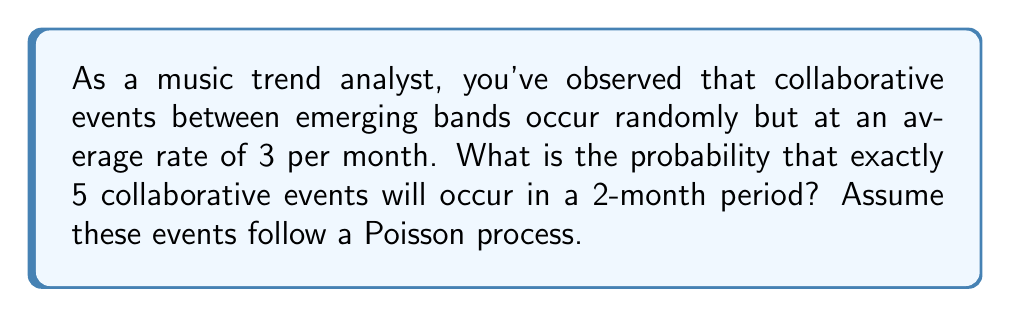What is the answer to this math problem? To solve this problem, we'll use the Poisson distribution, which is appropriate for modeling the number of events occurring in a fixed interval of time when these events happen at a known average rate and independently of each other.

Given:
- Average rate (λ) = 3 events per month
- Time period (t) = 2 months
- Number of events (k) = 5

Step 1: Calculate the average number of events for the given time period.
λt = 3 events/month × 2 months = 6 events

Step 2: Use the Poisson probability mass function:
$$P(X = k) = \frac{e^{-λt}(λt)^k}{k!}$$

Step 3: Substitute the values into the formula:
$$P(X = 5) = \frac{e^{-6}(6)^5}{5!}$$

Step 4: Calculate the result:
$$P(X = 5) = \frac{e^{-6} \times 7776}{120} \approx 0.1606$$

Therefore, the probability of exactly 5 collaborative events occurring in a 2-month period is approximately 0.1606 or 16.06%.
Answer: 0.1606 